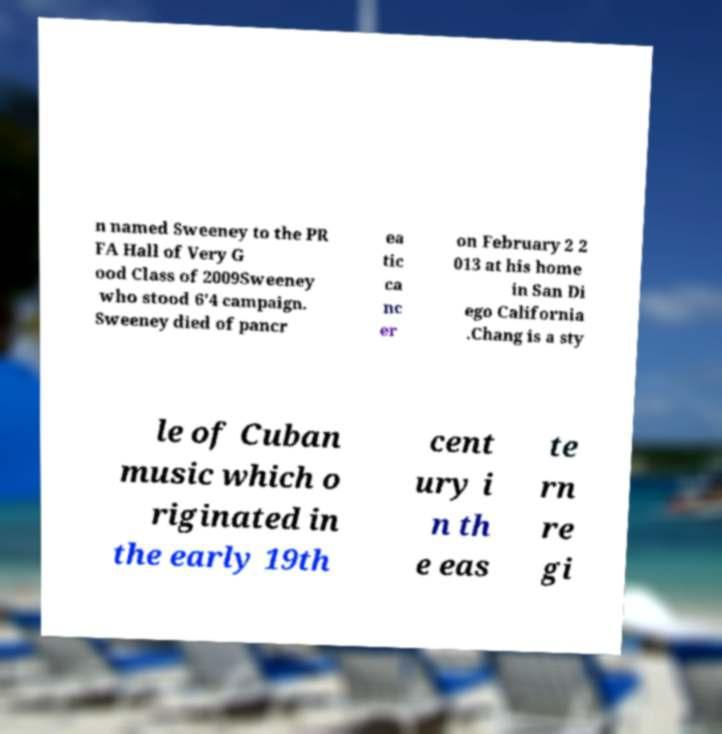Could you extract and type out the text from this image? n named Sweeney to the PR FA Hall of Very G ood Class of 2009Sweeney who stood 6'4 campaign. Sweeney died of pancr ea tic ca nc er on February 2 2 013 at his home in San Di ego California .Chang is a sty le of Cuban music which o riginated in the early 19th cent ury i n th e eas te rn re gi 